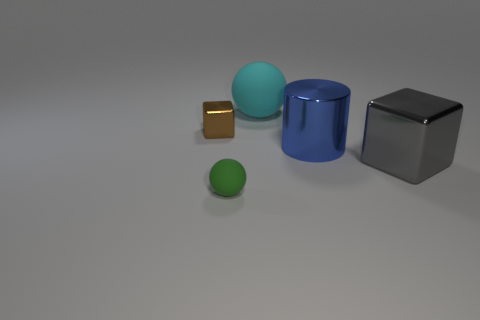Add 3 shiny objects. How many objects exist? 8 Subtract all spheres. How many objects are left? 3 Subtract all big cyan balls. Subtract all tiny spheres. How many objects are left? 3 Add 4 tiny rubber objects. How many tiny rubber objects are left? 5 Add 1 red shiny things. How many red shiny things exist? 1 Subtract 0 blue cubes. How many objects are left? 5 